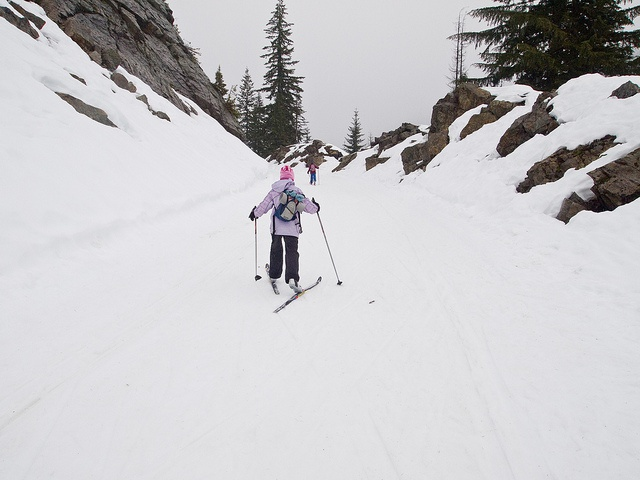Describe the objects in this image and their specific colors. I can see people in lavender, darkgray, black, and lightgray tones, backpack in lavender, darkgray, gray, navy, and black tones, people in lavender, white, gray, darkgray, and navy tones, skis in lavender, darkgray, gray, lightgray, and black tones, and skis in lavender, gray, darkgray, and black tones in this image. 